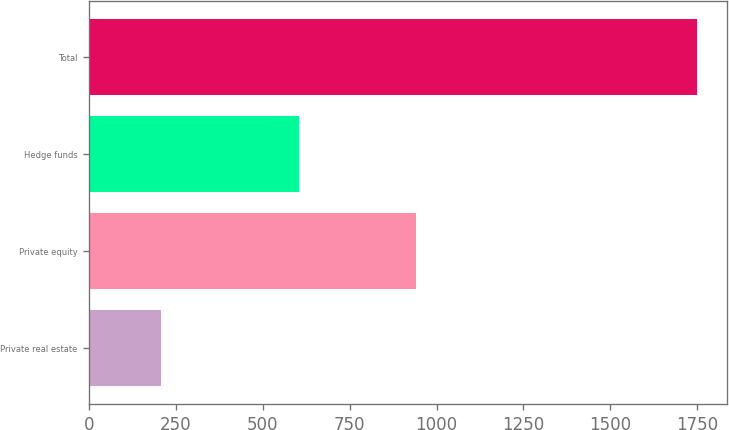Convert chart to OTSL. <chart><loc_0><loc_0><loc_500><loc_500><bar_chart><fcel>Private real estate<fcel>Private equity<fcel>Hedge funds<fcel>Total<nl><fcel>206<fcel>940<fcel>603<fcel>1749<nl></chart> 